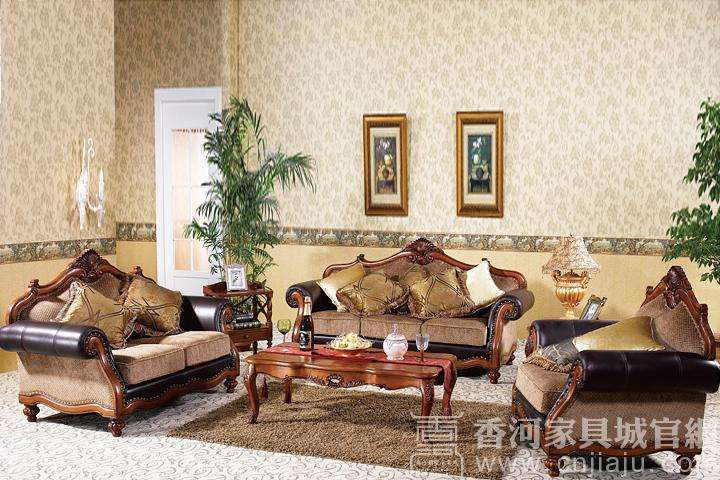Could this furniture be suitable for a small apartment? Given the size and ornate nature of the furniture in the image, it may not be the most suitable choice for a small apartment. These pieces typically require more space to avoid a cramped appearance and to fully appreciate their design. Smaller, more minimalistic furniture might be a better fit for limited spaces. 